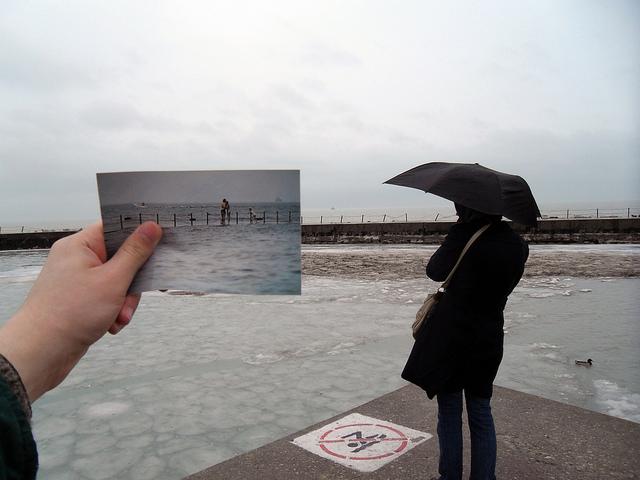Are they trying to recreate a photograph?
Be succinct. Yes. Is the weather cold or warm shown in the image?
Be succinct. Cold. What symbol is on the ground by the water?
Be succinct. No swimming. 